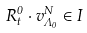<formula> <loc_0><loc_0><loc_500><loc_500>R _ { t } ^ { 0 } \cdot v _ { \Lambda _ { 0 } } ^ { N } \in I</formula> 